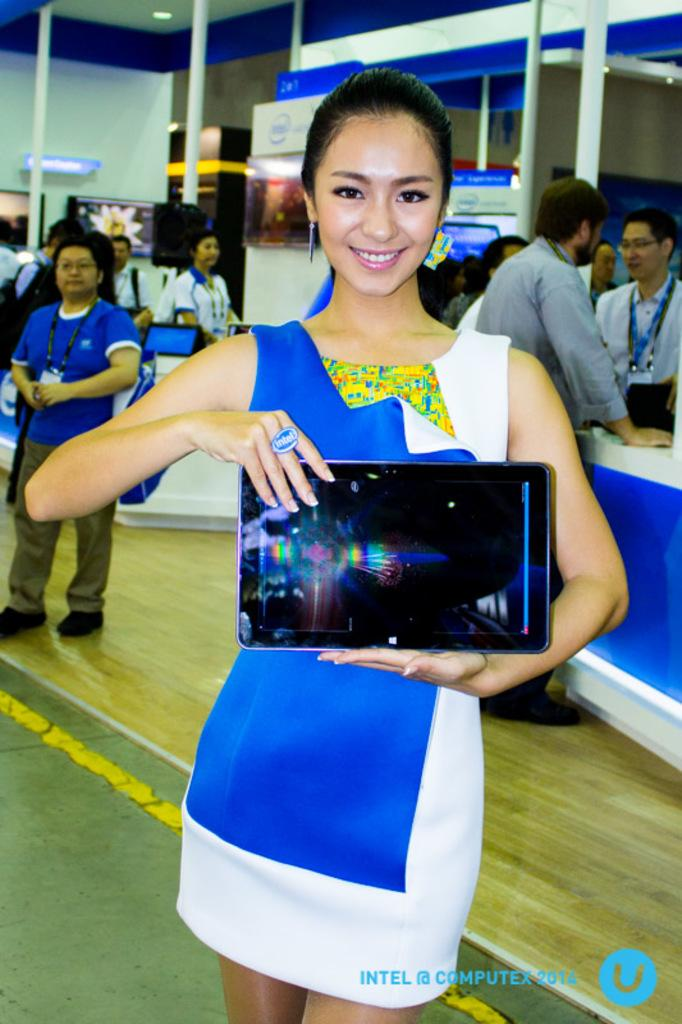Who is the main subject in the image? There is a woman in the image. What is the woman doing in the image? The woman is standing in the image. What is the woman holding in her hand? The woman is holding a tab in her hand. Are there any other people in the image? Yes, there are other persons standing behind her. What type of bottle is being tested by the wind in the image? There is no bottle or wind present in the image. 